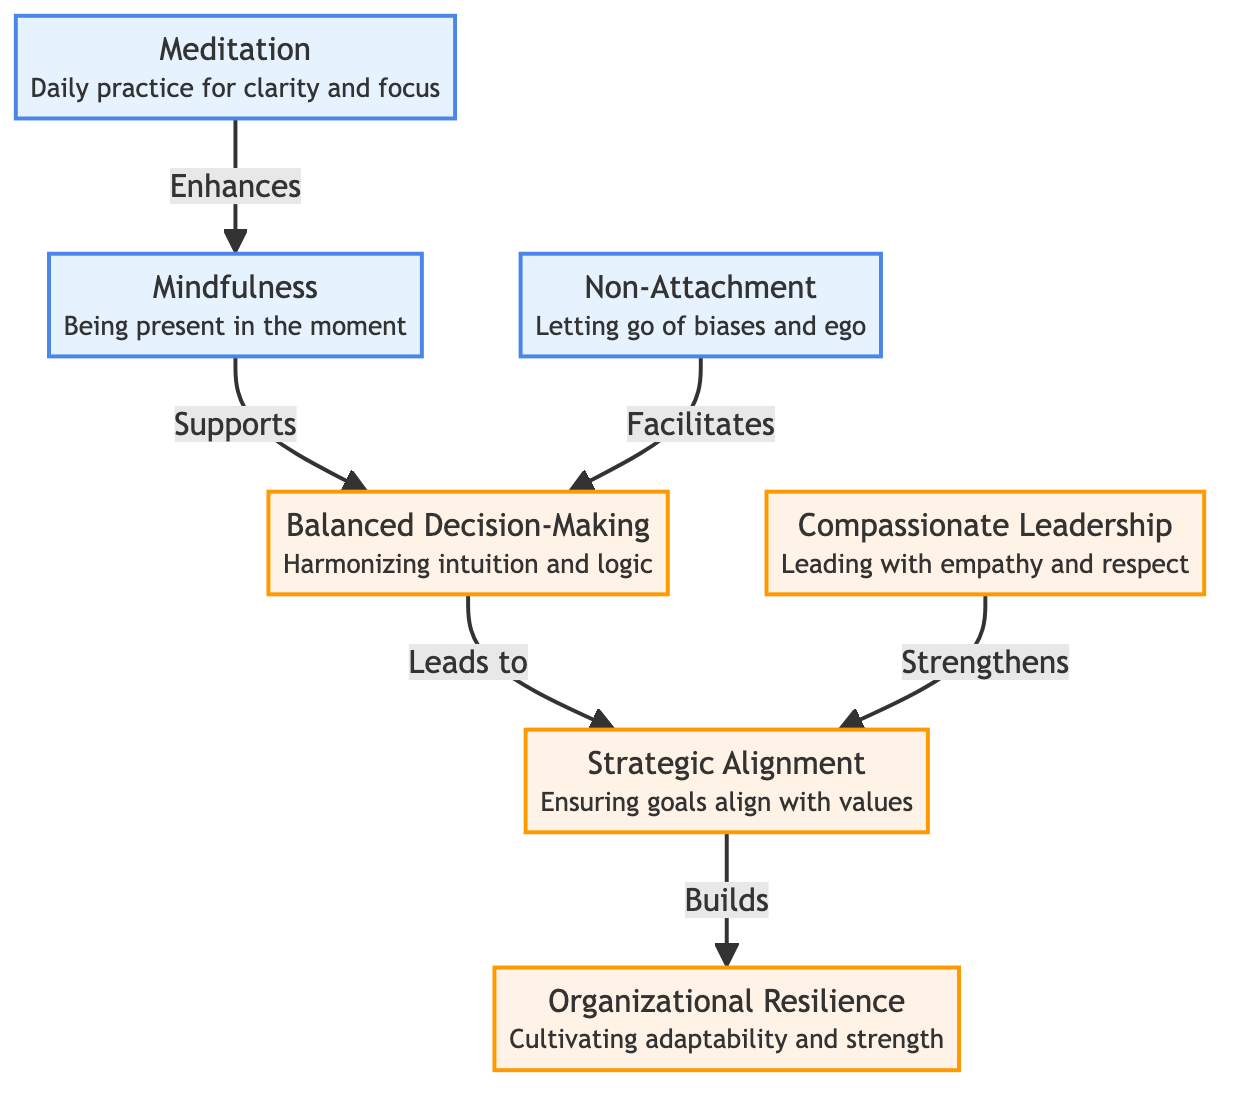What is the first node in the diagram? The first node in the diagram is "Meditation", which is positioned at the beginning of the flow, indicating it is the starting point for the subsequent principles.
Answer: Meditation How many zen principles are represented in the diagram? There are three zen principles in the diagram: "Meditation," "Mindfulness," and "Non-Attachment." These are distinct nodes that contribute to the overall flow of decision-making.
Answer: Three What type of decision-making is supported by "Mindfulness"? The type of decision-making supported by "Mindfulness" is "Balanced Decision-Making." This is evident from the diagram where an arrow points from "Mindfulness" to "Balanced Decision-Making."
Answer: Balanced Decision-Making Which node leads to "Organizational Resilience"? The node that leads to "Organizational Resilience" is "Strategic Alignment." The flow indicates that "Strategic Alignment" builds up to enhance "Organizational Resilience."
Answer: Strategic Alignment What does "Non-Attachment" facilitate in the diagram? "Non-Attachment" facilitates "Balanced Decision-Making." This can be observed from the directed edge connecting "Non-Attachment" directly to "Balanced Decision-Making."
Answer: Balanced Decision-Making What connects "Meditation" to "Mindfulness"? "Meditation" is connected to "Mindfulness" through the relationship labeled "Enhances," indicating that the practice of meditation enhances the quality of mindfulness.
Answer: Enhances How many edges are there originating from "Balanced Decision-Making"? There are two edges originating from "Balanced Decision-Making," one leading to "Strategic Alignment" and the other is connected to a node but has no outgoing edges beyond that.
Answer: Two Which principle strengthens "Strategic Alignment"? The principle that strengthens "Strategic Alignment" is "Compassionate Leadership," as depicted by a directed arrow from "Compassionate Leadership" directing towards "Strategic Alignment."
Answer: Compassionate Leadership What fundamentally relates to the clarity of decision-making in the diagram? "Meditation" fundamentally relates to the clarity of decision-making, as it is indicated that meditation enhances mindfulness, which supports balanced decision-making.
Answer: Meditation What is the ultimate outcome of incorporating the principles in this flowchart? The ultimate outcome of incorporating the principles from the flowchart is "Organizational Resilience," as it is the final node reached through all preceding relationships.
Answer: Organizational Resilience 